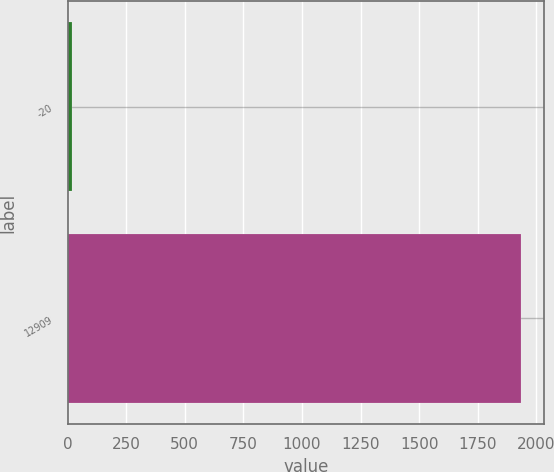Convert chart. <chart><loc_0><loc_0><loc_500><loc_500><bar_chart><fcel>-20<fcel>12909<nl><fcel>20<fcel>1936.4<nl></chart> 